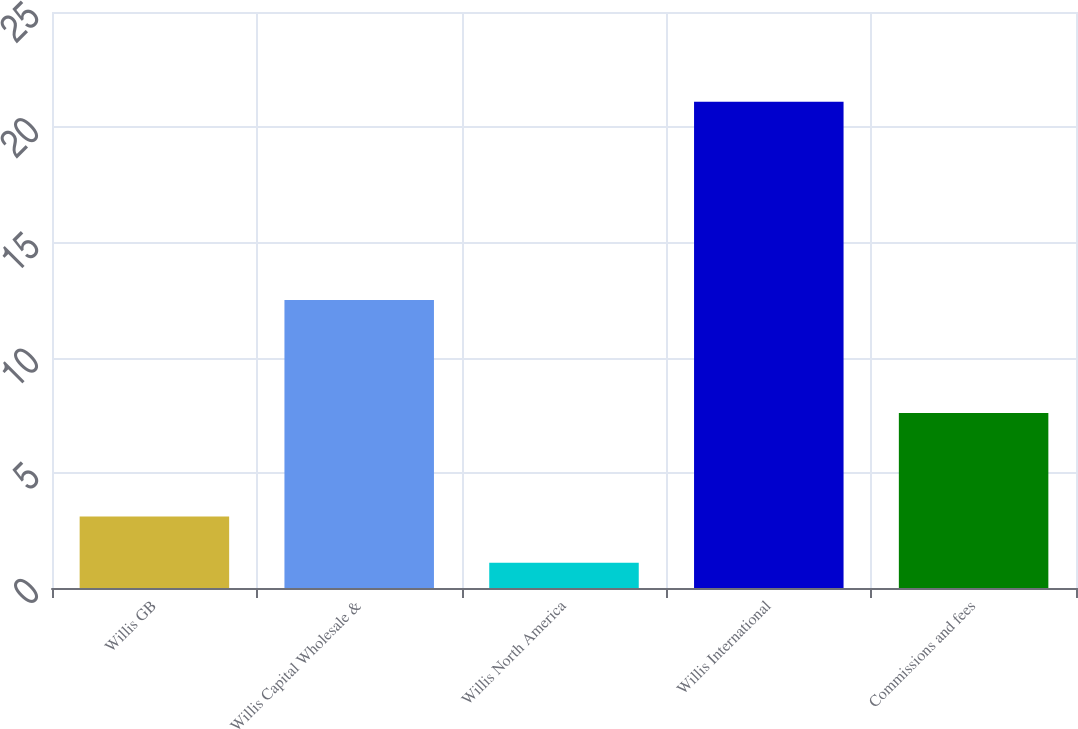<chart> <loc_0><loc_0><loc_500><loc_500><bar_chart><fcel>Willis GB<fcel>Willis Capital Wholesale &<fcel>Willis North America<fcel>Willis International<fcel>Commissions and fees<nl><fcel>3.1<fcel>12.5<fcel>1.1<fcel>21.1<fcel>7.6<nl></chart> 